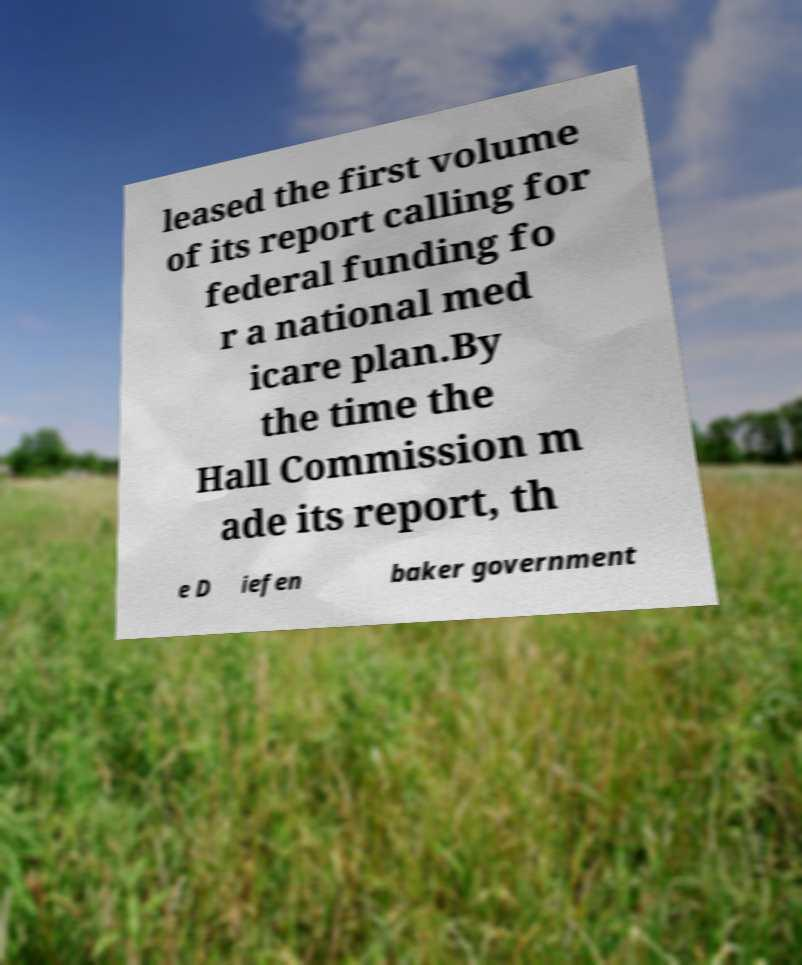Could you assist in decoding the text presented in this image and type it out clearly? leased the first volume of its report calling for federal funding fo r a national med icare plan.By the time the Hall Commission m ade its report, th e D iefen baker government 